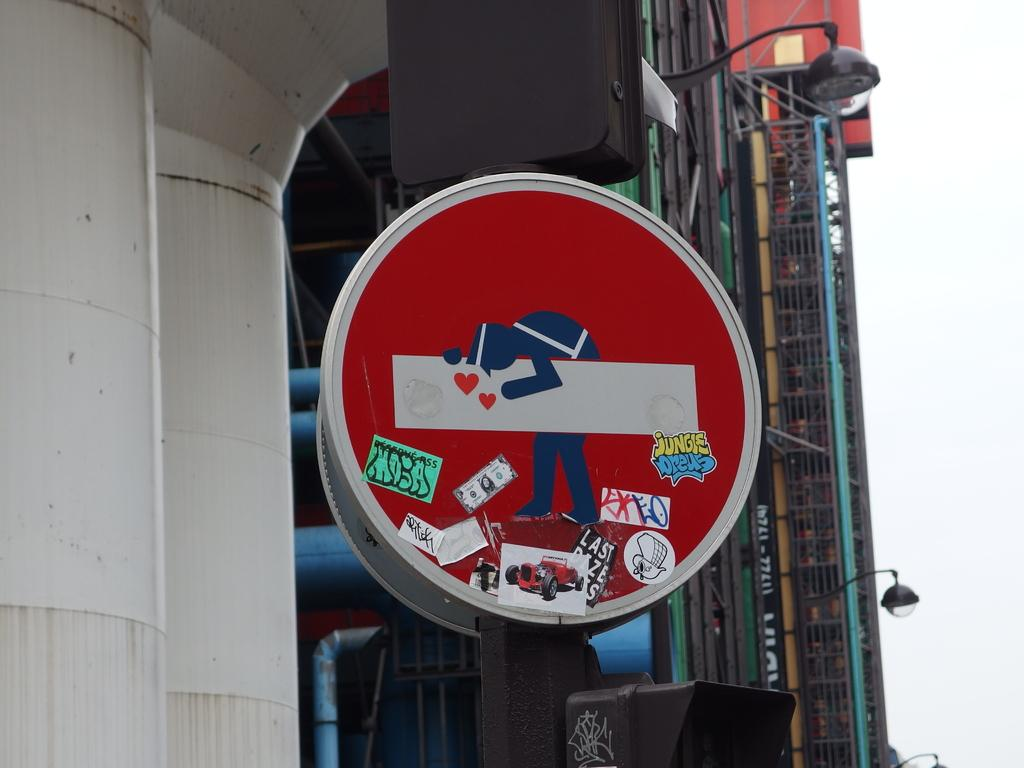<image>
Render a clear and concise summary of the photo. A red circular sign has a sticker on it that says Jungle Dreus. 